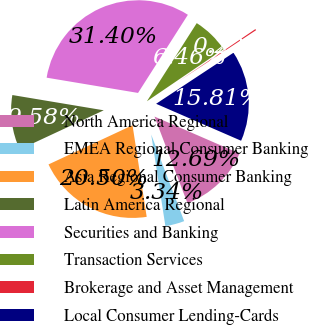Convert chart. <chart><loc_0><loc_0><loc_500><loc_500><pie_chart><fcel>North America Regional<fcel>EMEA Regional Consumer Banking<fcel>Asia Regional Consumer Banking<fcel>Latin America Regional<fcel>Securities and Banking<fcel>Transaction Services<fcel>Brokerage and Asset Management<fcel>Local Consumer Lending-Cards<nl><fcel>12.69%<fcel>3.34%<fcel>20.5%<fcel>9.58%<fcel>31.4%<fcel>6.46%<fcel>0.22%<fcel>15.81%<nl></chart> 